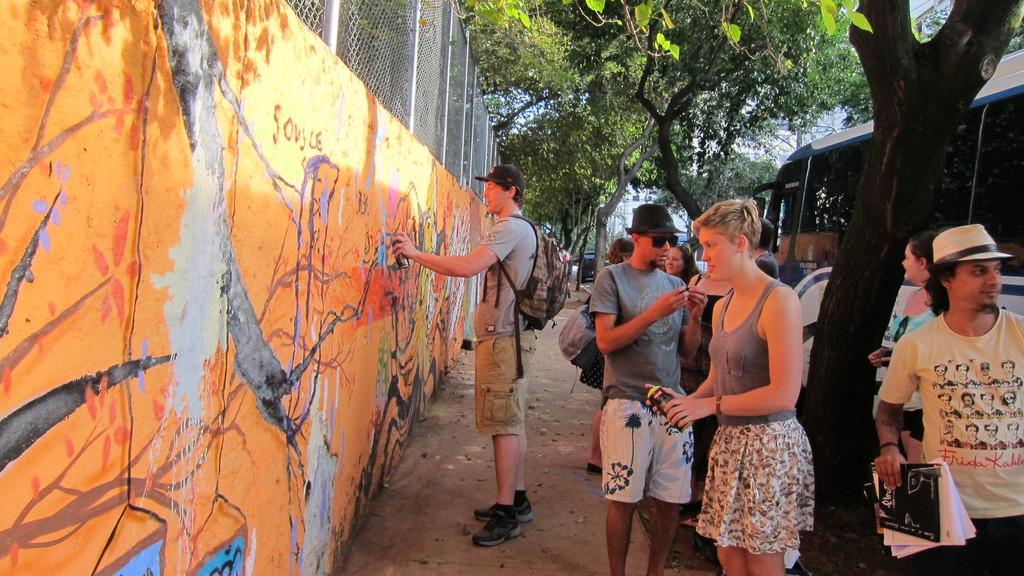What are the people in the image doing? The people in the image are standing and holding papers in their hands. What can be seen in the background of the image? There are trees visible in the background of the image. What type of nail is being used by the person in the image? There is no nail visible in the image; the people are holding papers in their hands. Is there a doctor present in the image? There is no indication of a doctor or any medical professionals in the image. 